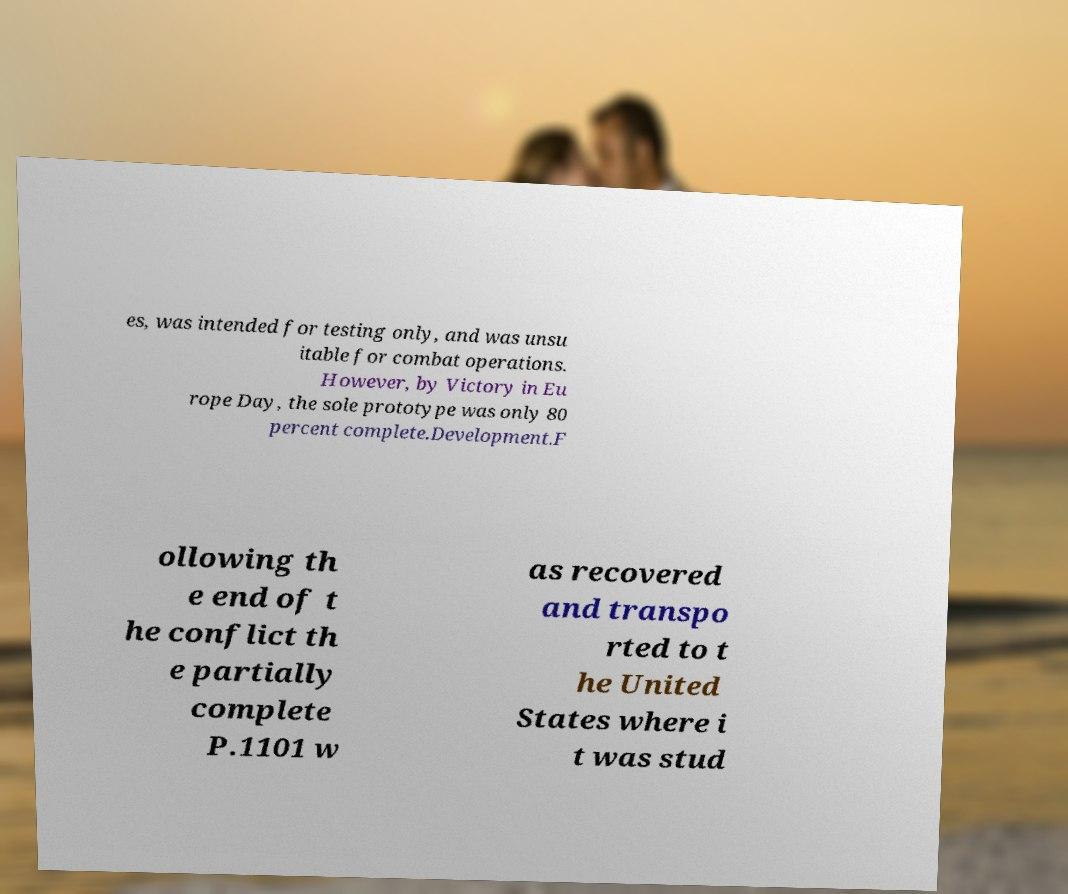Can you read and provide the text displayed in the image?This photo seems to have some interesting text. Can you extract and type it out for me? es, was intended for testing only, and was unsu itable for combat operations. However, by Victory in Eu rope Day, the sole prototype was only 80 percent complete.Development.F ollowing th e end of t he conflict th e partially complete P.1101 w as recovered and transpo rted to t he United States where i t was stud 